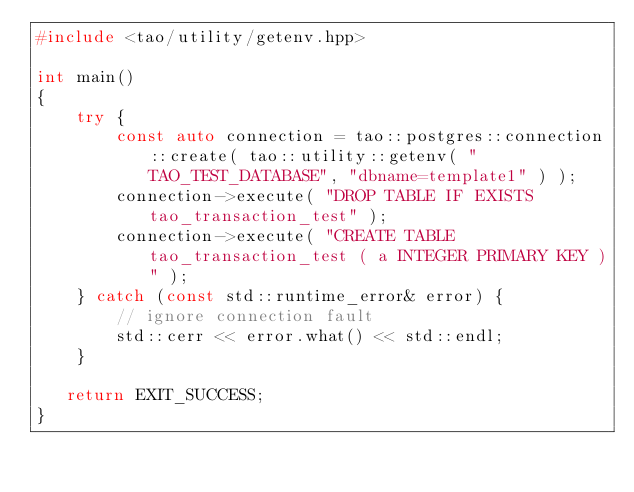Convert code to text. <code><loc_0><loc_0><loc_500><loc_500><_C++_>#include <tao/utility/getenv.hpp>

int main()
{
    try {
        const auto connection = tao::postgres::connection::create( tao::utility::getenv( "TAO_TEST_DATABASE", "dbname=template1" ) );
        connection->execute( "DROP TABLE IF EXISTS tao_transaction_test" );
        connection->execute( "CREATE TABLE tao_transaction_test ( a INTEGER PRIMARY KEY )" );
    } catch (const std::runtime_error& error) {
        // ignore connection fault
        std::cerr << error.what() << std::endl;
    }

   return EXIT_SUCCESS;
}
</code> 